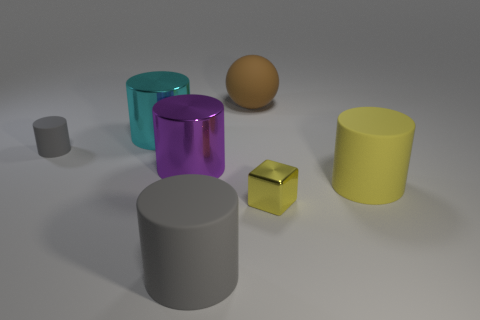How many other objects are there of the same material as the tiny cube? In the image, there are two objects that appear to be of the same shiny, metallic material as the tiny cube: a large cylinder and a sphere. 